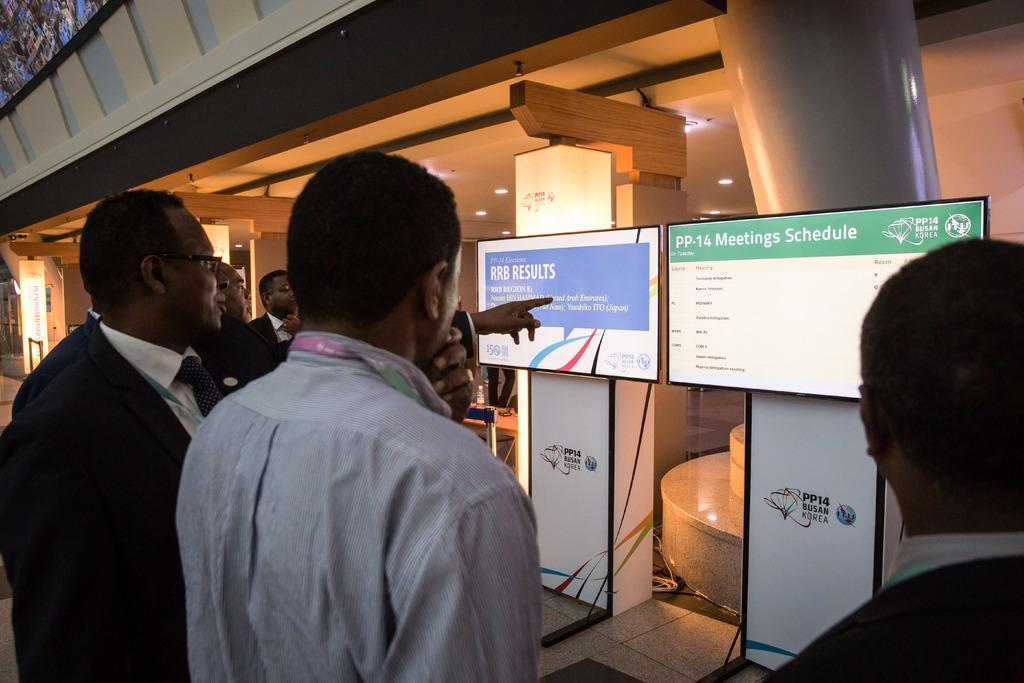What is happening in the center of the image? There are people standing in the center of the image. What can be seen in the background of the image? There are screens and walls in the background of the image. What is visible at the top of the image? There are lights visible at the top of the image. Where is the nest located in the image? There is no nest present in the image. How many mice can be seen running around in the image? There are no mice present in the image. 